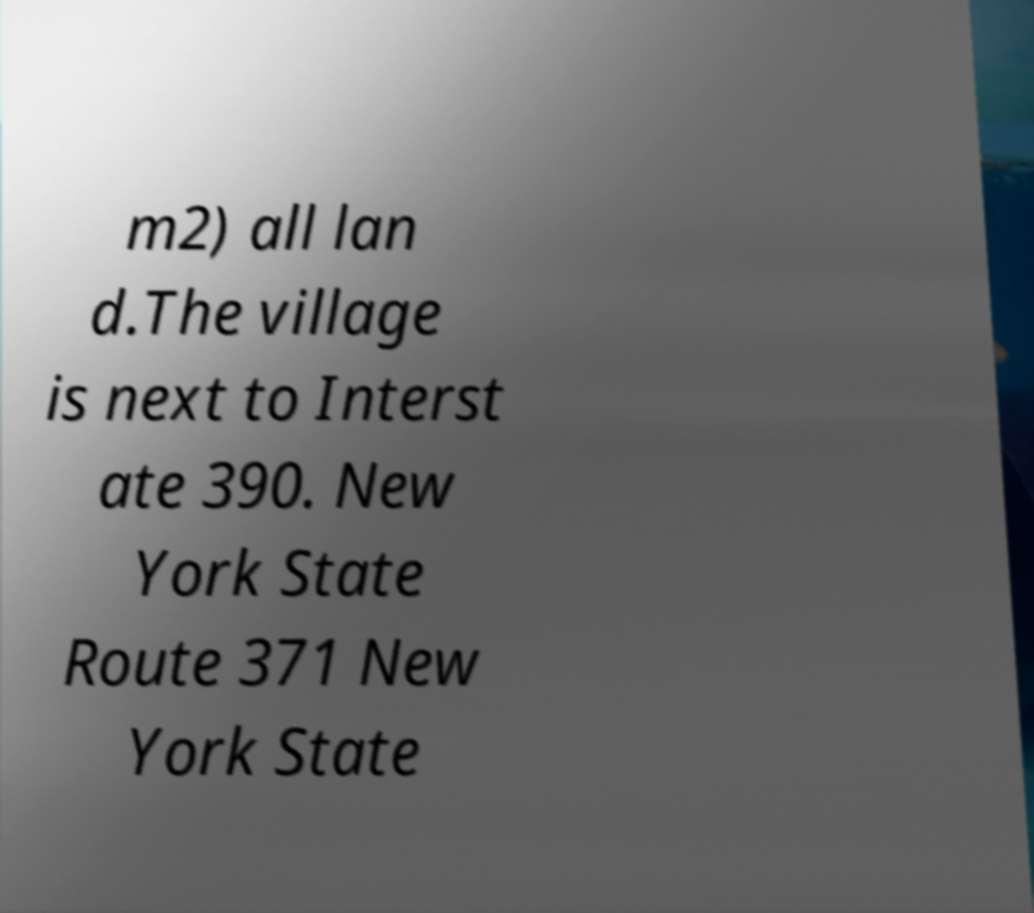Can you read and provide the text displayed in the image?This photo seems to have some interesting text. Can you extract and type it out for me? m2) all lan d.The village is next to Interst ate 390. New York State Route 371 New York State 